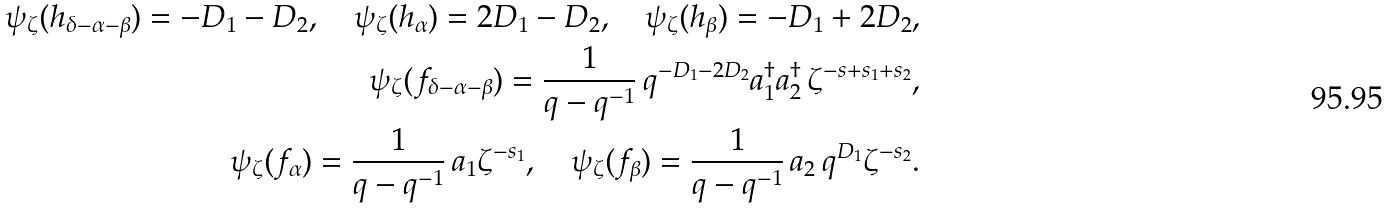Convert formula to latex. <formula><loc_0><loc_0><loc_500><loc_500>\psi _ { \zeta } ( h _ { \delta - \alpha - \beta } ) = - D _ { 1 } - D _ { 2 } , \quad \psi _ { \zeta } ( h _ { \alpha } ) = 2 D _ { 1 } - D _ { 2 } , \quad \psi _ { \zeta } ( h _ { \beta } ) = - D _ { 1 } + 2 D _ { 2 } , \\ \psi _ { \zeta } ( f _ { \delta - \alpha - \beta } ) = \frac { 1 } { q - q ^ { - 1 } } \, q ^ { - D _ { 1 } - 2 D _ { 2 } } a _ { 1 } ^ { \dagger } a _ { 2 } ^ { \dagger } \, \zeta ^ { - s + s _ { 1 } + s _ { 2 } } , \\ \psi _ { \zeta } ( f _ { \alpha } ) = \frac { 1 } { q - q ^ { - 1 } } \, a _ { 1 } \zeta ^ { - s _ { 1 } } , \quad \psi _ { \zeta } ( f _ { \beta } ) = \frac { 1 } { q - q ^ { - 1 } } \, a _ { 2 } \, q ^ { D _ { 1 } } \zeta ^ { - s _ { 2 } } .</formula> 